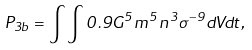Convert formula to latex. <formula><loc_0><loc_0><loc_500><loc_500>P _ { 3 b } = \int \int 0 . 9 G ^ { 5 } m ^ { 5 } n ^ { 3 } \sigma ^ { - 9 } d V d t ,</formula> 